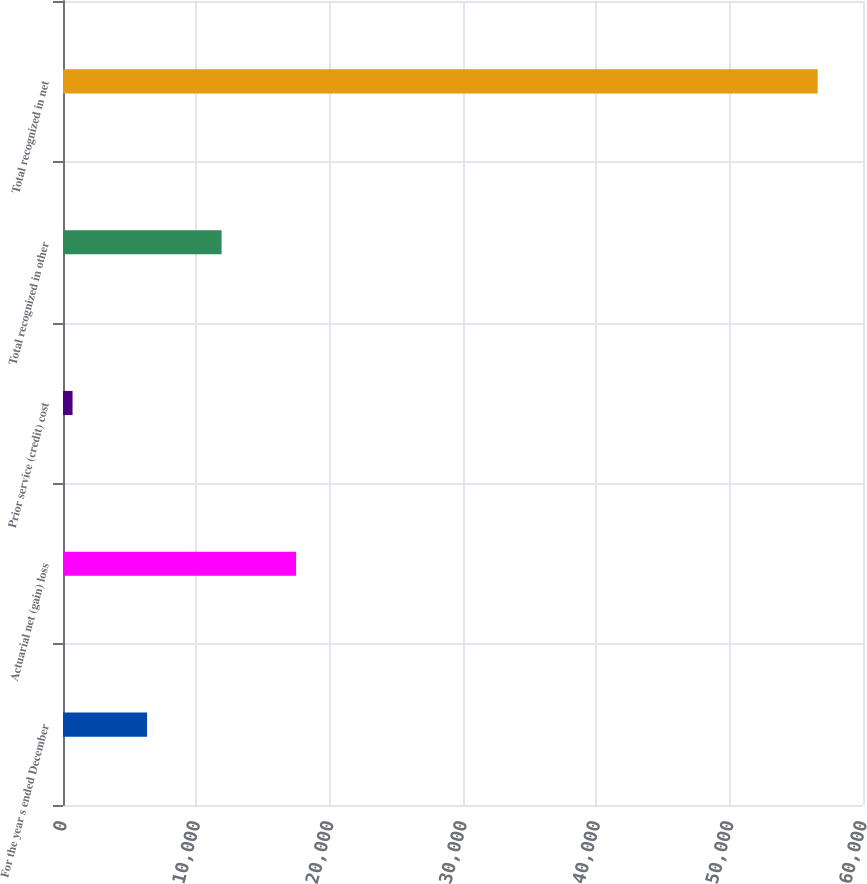Convert chart to OTSL. <chart><loc_0><loc_0><loc_500><loc_500><bar_chart><fcel>For the year s ended December<fcel>Actuarial net (gain) loss<fcel>Prior service (credit) cost<fcel>Total recognized in other<fcel>Total recognized in net<nl><fcel>6304.6<fcel>17481.8<fcel>716<fcel>11893.2<fcel>56602<nl></chart> 